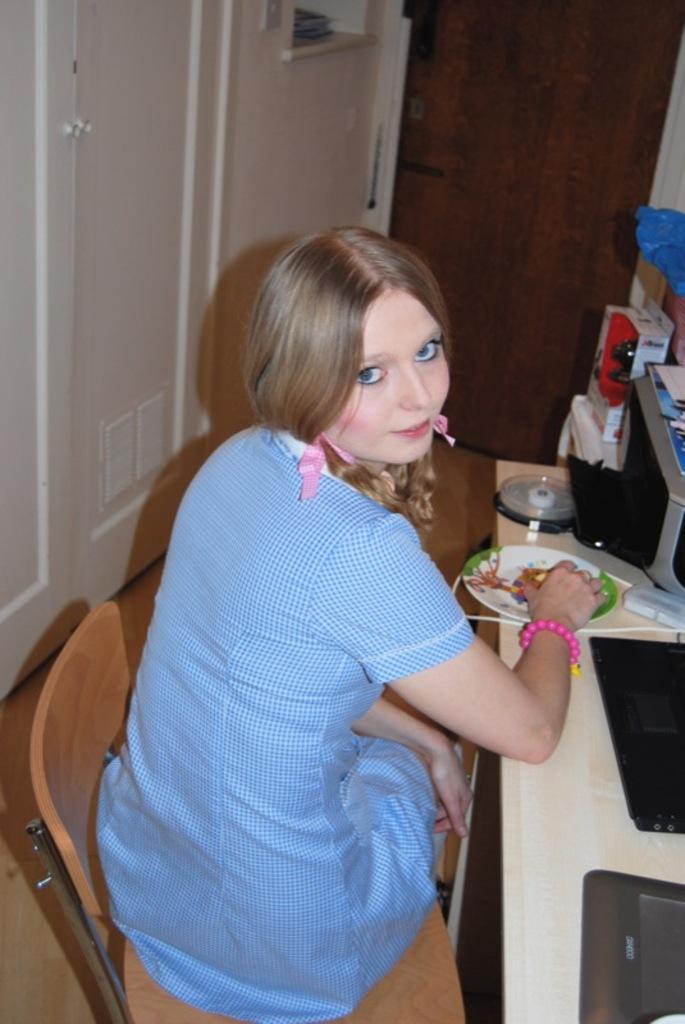What is the woman doing in the image? The woman is sitting on a chair in the image. What is in front of the woman? There is a table in front of the woman. What can be seen on the table? There are plates and objects on the table. What is located behind the woman? There is a door behind the woman. How many apples are on the hill in the image? There is no hill or apples present in the image. 